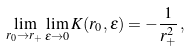Convert formula to latex. <formula><loc_0><loc_0><loc_500><loc_500>\lim _ { r _ { 0 } \rightarrow r _ { + } } \lim _ { \varepsilon \rightarrow 0 } K ( r _ { 0 } , \varepsilon ) = - \frac { 1 } { r _ { + } ^ { 2 } } \, ,</formula> 